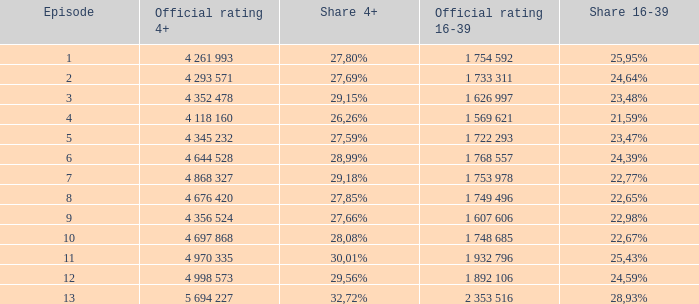What is the 16-39 share of the episode with a 4+ share of 30,01%? 25,43%. 